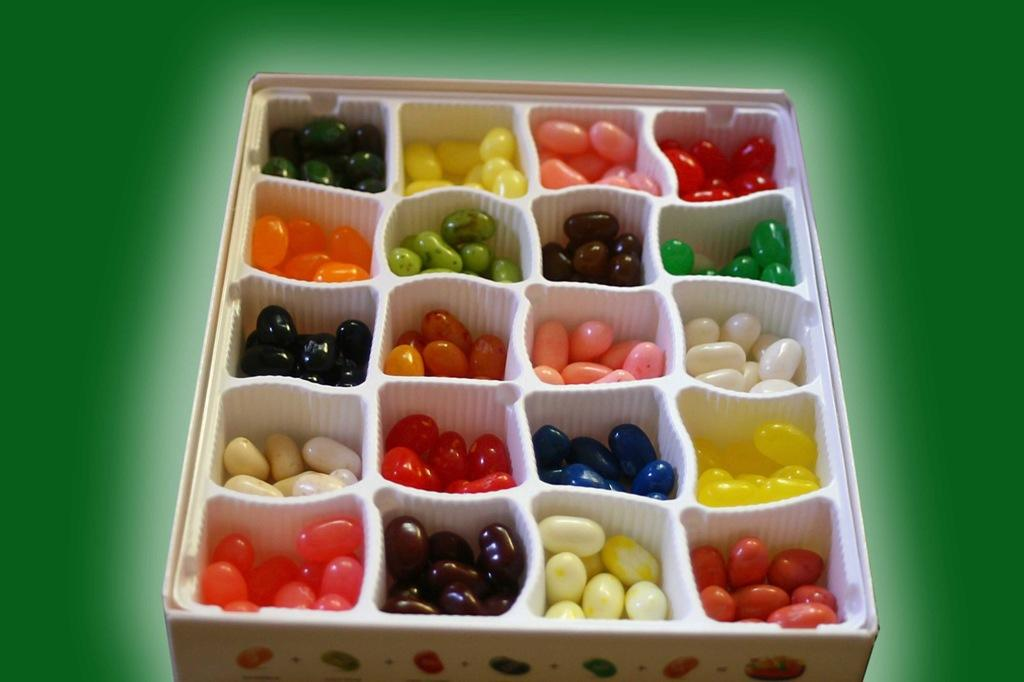What type of objects are present in the image? There are colorful gems in the image. Can you describe the appearance of the gems? The gems are colorful, which suggests they come in various shades and hues. What might be the purpose of these gems? The purpose of these gems is not explicitly stated in the image, but they could be used for decoration, jewelry, or even as collectibles. What type of pear is being requested by the grandfather in the image? There is no pear or grandfather present in the image; it only features colorful gems. 